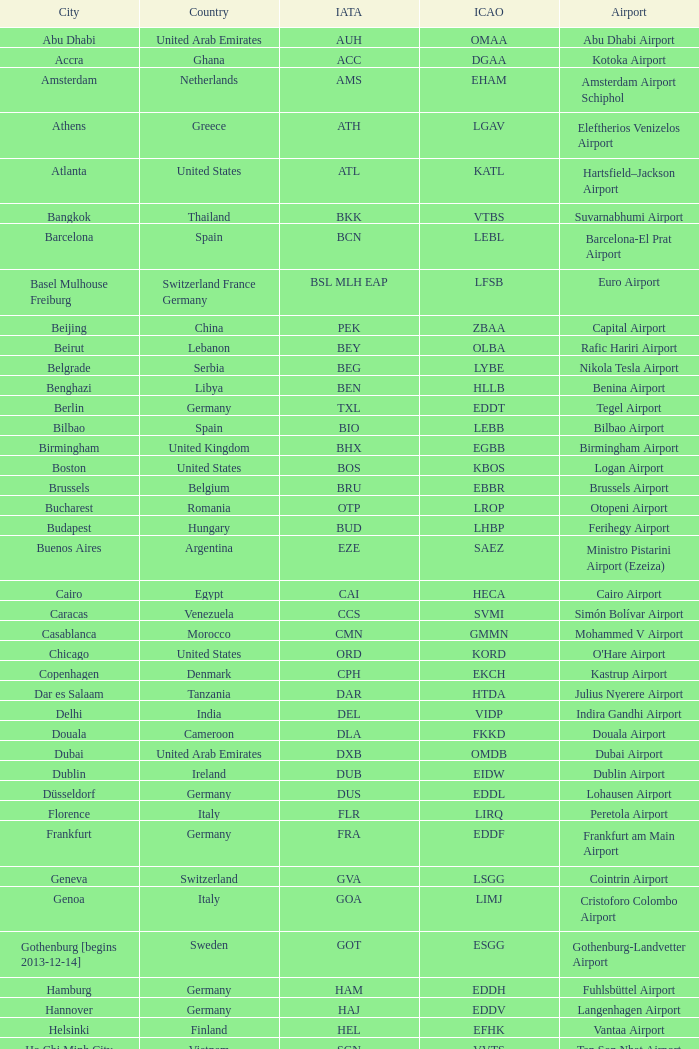What is the iata identifier for galeão airport? GIG. 